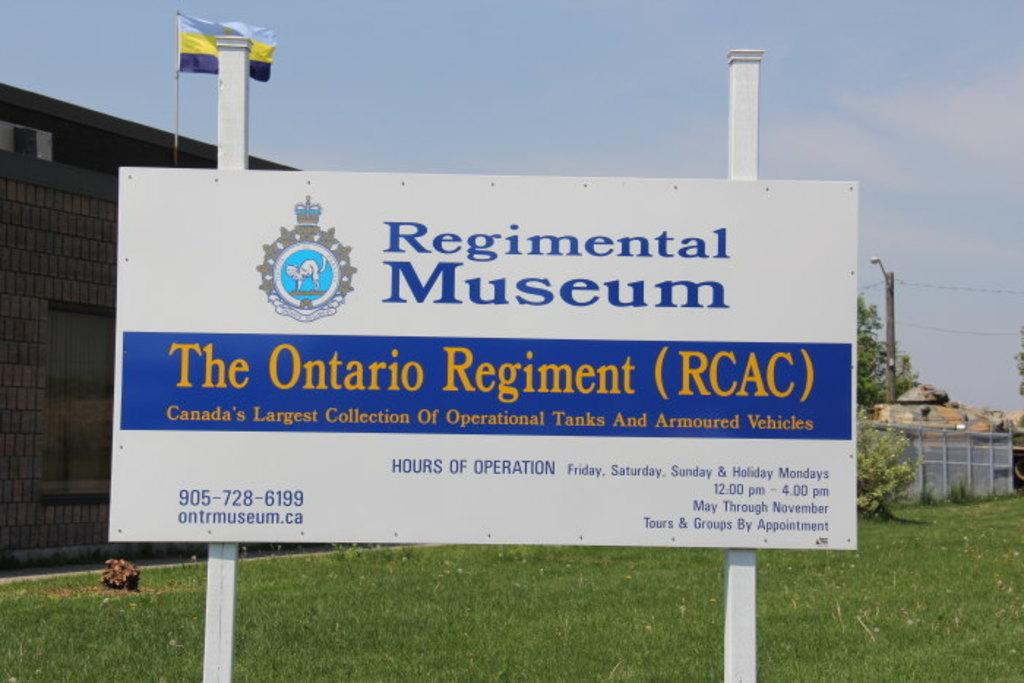<image>
Present a compact description of the photo's key features. a sign from the ontario regiment that says museum 